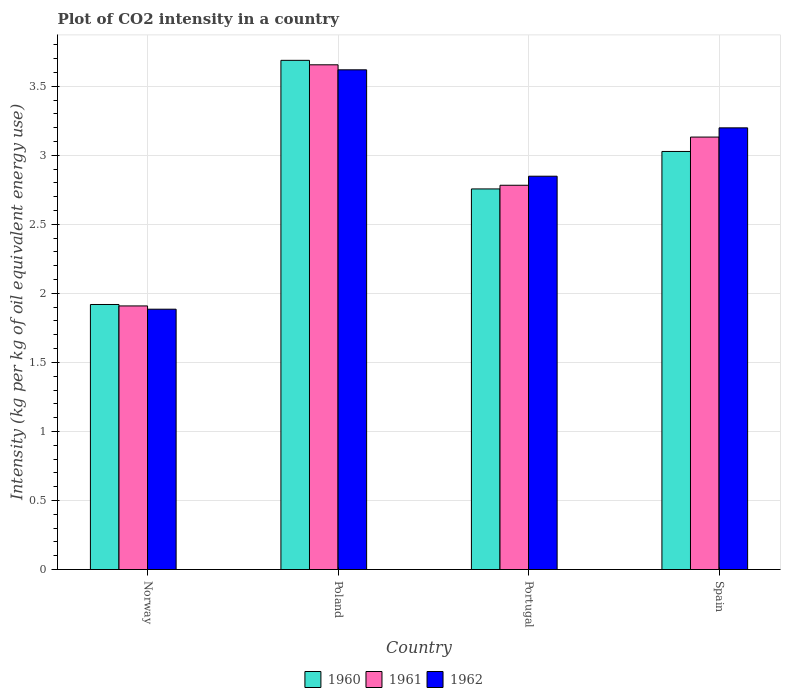How many groups of bars are there?
Provide a succinct answer. 4. Are the number of bars per tick equal to the number of legend labels?
Your answer should be compact. Yes. Are the number of bars on each tick of the X-axis equal?
Give a very brief answer. Yes. How many bars are there on the 2nd tick from the left?
Your response must be concise. 3. In how many cases, is the number of bars for a given country not equal to the number of legend labels?
Give a very brief answer. 0. What is the CO2 intensity in in 1960 in Norway?
Provide a succinct answer. 1.92. Across all countries, what is the maximum CO2 intensity in in 1961?
Your response must be concise. 3.66. Across all countries, what is the minimum CO2 intensity in in 1962?
Make the answer very short. 1.89. In which country was the CO2 intensity in in 1960 maximum?
Provide a succinct answer. Poland. What is the total CO2 intensity in in 1962 in the graph?
Make the answer very short. 11.55. What is the difference between the CO2 intensity in in 1961 in Poland and that in Spain?
Your response must be concise. 0.52. What is the difference between the CO2 intensity in in 1960 in Portugal and the CO2 intensity in in 1961 in Spain?
Make the answer very short. -0.38. What is the average CO2 intensity in in 1961 per country?
Provide a short and direct response. 2.87. What is the difference between the CO2 intensity in of/in 1961 and CO2 intensity in of/in 1962 in Norway?
Provide a succinct answer. 0.02. What is the ratio of the CO2 intensity in in 1962 in Portugal to that in Spain?
Offer a terse response. 0.89. Is the difference between the CO2 intensity in in 1961 in Poland and Spain greater than the difference between the CO2 intensity in in 1962 in Poland and Spain?
Provide a succinct answer. Yes. What is the difference between the highest and the second highest CO2 intensity in in 1962?
Ensure brevity in your answer.  0.35. What is the difference between the highest and the lowest CO2 intensity in in 1960?
Keep it short and to the point. 1.77. In how many countries, is the CO2 intensity in in 1962 greater than the average CO2 intensity in in 1962 taken over all countries?
Ensure brevity in your answer.  2. Is the sum of the CO2 intensity in in 1962 in Norway and Portugal greater than the maximum CO2 intensity in in 1960 across all countries?
Provide a short and direct response. Yes. How many bars are there?
Offer a very short reply. 12. How many countries are there in the graph?
Your answer should be very brief. 4. What is the difference between two consecutive major ticks on the Y-axis?
Give a very brief answer. 0.5. Does the graph contain any zero values?
Provide a short and direct response. No. How many legend labels are there?
Make the answer very short. 3. What is the title of the graph?
Make the answer very short. Plot of CO2 intensity in a country. Does "1994" appear as one of the legend labels in the graph?
Keep it short and to the point. No. What is the label or title of the X-axis?
Give a very brief answer. Country. What is the label or title of the Y-axis?
Offer a terse response. Intensity (kg per kg of oil equivalent energy use). What is the Intensity (kg per kg of oil equivalent energy use) in 1960 in Norway?
Your answer should be compact. 1.92. What is the Intensity (kg per kg of oil equivalent energy use) in 1961 in Norway?
Your answer should be very brief. 1.91. What is the Intensity (kg per kg of oil equivalent energy use) of 1962 in Norway?
Keep it short and to the point. 1.89. What is the Intensity (kg per kg of oil equivalent energy use) of 1960 in Poland?
Offer a very short reply. 3.69. What is the Intensity (kg per kg of oil equivalent energy use) in 1961 in Poland?
Offer a terse response. 3.66. What is the Intensity (kg per kg of oil equivalent energy use) of 1962 in Poland?
Give a very brief answer. 3.62. What is the Intensity (kg per kg of oil equivalent energy use) of 1960 in Portugal?
Make the answer very short. 2.76. What is the Intensity (kg per kg of oil equivalent energy use) in 1961 in Portugal?
Offer a very short reply. 2.78. What is the Intensity (kg per kg of oil equivalent energy use) of 1962 in Portugal?
Your response must be concise. 2.85. What is the Intensity (kg per kg of oil equivalent energy use) in 1960 in Spain?
Ensure brevity in your answer.  3.03. What is the Intensity (kg per kg of oil equivalent energy use) of 1961 in Spain?
Your answer should be compact. 3.13. What is the Intensity (kg per kg of oil equivalent energy use) of 1962 in Spain?
Provide a succinct answer. 3.2. Across all countries, what is the maximum Intensity (kg per kg of oil equivalent energy use) in 1960?
Ensure brevity in your answer.  3.69. Across all countries, what is the maximum Intensity (kg per kg of oil equivalent energy use) of 1961?
Provide a short and direct response. 3.66. Across all countries, what is the maximum Intensity (kg per kg of oil equivalent energy use) of 1962?
Keep it short and to the point. 3.62. Across all countries, what is the minimum Intensity (kg per kg of oil equivalent energy use) of 1960?
Ensure brevity in your answer.  1.92. Across all countries, what is the minimum Intensity (kg per kg of oil equivalent energy use) in 1961?
Provide a short and direct response. 1.91. Across all countries, what is the minimum Intensity (kg per kg of oil equivalent energy use) of 1962?
Offer a terse response. 1.89. What is the total Intensity (kg per kg of oil equivalent energy use) in 1960 in the graph?
Your response must be concise. 11.39. What is the total Intensity (kg per kg of oil equivalent energy use) of 1961 in the graph?
Offer a terse response. 11.48. What is the total Intensity (kg per kg of oil equivalent energy use) of 1962 in the graph?
Make the answer very short. 11.55. What is the difference between the Intensity (kg per kg of oil equivalent energy use) of 1960 in Norway and that in Poland?
Offer a very short reply. -1.77. What is the difference between the Intensity (kg per kg of oil equivalent energy use) of 1961 in Norway and that in Poland?
Your answer should be very brief. -1.75. What is the difference between the Intensity (kg per kg of oil equivalent energy use) in 1962 in Norway and that in Poland?
Provide a short and direct response. -1.73. What is the difference between the Intensity (kg per kg of oil equivalent energy use) of 1960 in Norway and that in Portugal?
Your response must be concise. -0.84. What is the difference between the Intensity (kg per kg of oil equivalent energy use) of 1961 in Norway and that in Portugal?
Ensure brevity in your answer.  -0.87. What is the difference between the Intensity (kg per kg of oil equivalent energy use) of 1962 in Norway and that in Portugal?
Give a very brief answer. -0.96. What is the difference between the Intensity (kg per kg of oil equivalent energy use) of 1960 in Norway and that in Spain?
Your answer should be very brief. -1.11. What is the difference between the Intensity (kg per kg of oil equivalent energy use) of 1961 in Norway and that in Spain?
Your answer should be very brief. -1.22. What is the difference between the Intensity (kg per kg of oil equivalent energy use) of 1962 in Norway and that in Spain?
Offer a very short reply. -1.31. What is the difference between the Intensity (kg per kg of oil equivalent energy use) of 1960 in Poland and that in Portugal?
Offer a very short reply. 0.93. What is the difference between the Intensity (kg per kg of oil equivalent energy use) in 1961 in Poland and that in Portugal?
Make the answer very short. 0.87. What is the difference between the Intensity (kg per kg of oil equivalent energy use) in 1962 in Poland and that in Portugal?
Offer a very short reply. 0.77. What is the difference between the Intensity (kg per kg of oil equivalent energy use) in 1960 in Poland and that in Spain?
Your answer should be compact. 0.66. What is the difference between the Intensity (kg per kg of oil equivalent energy use) in 1961 in Poland and that in Spain?
Offer a terse response. 0.52. What is the difference between the Intensity (kg per kg of oil equivalent energy use) in 1962 in Poland and that in Spain?
Offer a terse response. 0.42. What is the difference between the Intensity (kg per kg of oil equivalent energy use) in 1960 in Portugal and that in Spain?
Offer a very short reply. -0.27. What is the difference between the Intensity (kg per kg of oil equivalent energy use) in 1961 in Portugal and that in Spain?
Your answer should be compact. -0.35. What is the difference between the Intensity (kg per kg of oil equivalent energy use) in 1962 in Portugal and that in Spain?
Your answer should be very brief. -0.35. What is the difference between the Intensity (kg per kg of oil equivalent energy use) in 1960 in Norway and the Intensity (kg per kg of oil equivalent energy use) in 1961 in Poland?
Offer a terse response. -1.74. What is the difference between the Intensity (kg per kg of oil equivalent energy use) of 1960 in Norway and the Intensity (kg per kg of oil equivalent energy use) of 1962 in Poland?
Your response must be concise. -1.7. What is the difference between the Intensity (kg per kg of oil equivalent energy use) of 1961 in Norway and the Intensity (kg per kg of oil equivalent energy use) of 1962 in Poland?
Offer a terse response. -1.71. What is the difference between the Intensity (kg per kg of oil equivalent energy use) in 1960 in Norway and the Intensity (kg per kg of oil equivalent energy use) in 1961 in Portugal?
Give a very brief answer. -0.86. What is the difference between the Intensity (kg per kg of oil equivalent energy use) in 1960 in Norway and the Intensity (kg per kg of oil equivalent energy use) in 1962 in Portugal?
Your response must be concise. -0.93. What is the difference between the Intensity (kg per kg of oil equivalent energy use) of 1961 in Norway and the Intensity (kg per kg of oil equivalent energy use) of 1962 in Portugal?
Your answer should be very brief. -0.94. What is the difference between the Intensity (kg per kg of oil equivalent energy use) in 1960 in Norway and the Intensity (kg per kg of oil equivalent energy use) in 1961 in Spain?
Give a very brief answer. -1.21. What is the difference between the Intensity (kg per kg of oil equivalent energy use) of 1960 in Norway and the Intensity (kg per kg of oil equivalent energy use) of 1962 in Spain?
Your answer should be compact. -1.28. What is the difference between the Intensity (kg per kg of oil equivalent energy use) of 1961 in Norway and the Intensity (kg per kg of oil equivalent energy use) of 1962 in Spain?
Provide a succinct answer. -1.29. What is the difference between the Intensity (kg per kg of oil equivalent energy use) in 1960 in Poland and the Intensity (kg per kg of oil equivalent energy use) in 1961 in Portugal?
Provide a succinct answer. 0.9. What is the difference between the Intensity (kg per kg of oil equivalent energy use) of 1960 in Poland and the Intensity (kg per kg of oil equivalent energy use) of 1962 in Portugal?
Give a very brief answer. 0.84. What is the difference between the Intensity (kg per kg of oil equivalent energy use) in 1961 in Poland and the Intensity (kg per kg of oil equivalent energy use) in 1962 in Portugal?
Give a very brief answer. 0.81. What is the difference between the Intensity (kg per kg of oil equivalent energy use) of 1960 in Poland and the Intensity (kg per kg of oil equivalent energy use) of 1961 in Spain?
Make the answer very short. 0.56. What is the difference between the Intensity (kg per kg of oil equivalent energy use) in 1960 in Poland and the Intensity (kg per kg of oil equivalent energy use) in 1962 in Spain?
Offer a terse response. 0.49. What is the difference between the Intensity (kg per kg of oil equivalent energy use) of 1961 in Poland and the Intensity (kg per kg of oil equivalent energy use) of 1962 in Spain?
Your answer should be very brief. 0.46. What is the difference between the Intensity (kg per kg of oil equivalent energy use) in 1960 in Portugal and the Intensity (kg per kg of oil equivalent energy use) in 1961 in Spain?
Your answer should be very brief. -0.38. What is the difference between the Intensity (kg per kg of oil equivalent energy use) in 1960 in Portugal and the Intensity (kg per kg of oil equivalent energy use) in 1962 in Spain?
Offer a very short reply. -0.44. What is the difference between the Intensity (kg per kg of oil equivalent energy use) in 1961 in Portugal and the Intensity (kg per kg of oil equivalent energy use) in 1962 in Spain?
Ensure brevity in your answer.  -0.42. What is the average Intensity (kg per kg of oil equivalent energy use) in 1960 per country?
Offer a very short reply. 2.85. What is the average Intensity (kg per kg of oil equivalent energy use) of 1961 per country?
Give a very brief answer. 2.87. What is the average Intensity (kg per kg of oil equivalent energy use) of 1962 per country?
Give a very brief answer. 2.89. What is the difference between the Intensity (kg per kg of oil equivalent energy use) of 1960 and Intensity (kg per kg of oil equivalent energy use) of 1961 in Norway?
Provide a succinct answer. 0.01. What is the difference between the Intensity (kg per kg of oil equivalent energy use) of 1960 and Intensity (kg per kg of oil equivalent energy use) of 1962 in Norway?
Offer a terse response. 0.03. What is the difference between the Intensity (kg per kg of oil equivalent energy use) in 1961 and Intensity (kg per kg of oil equivalent energy use) in 1962 in Norway?
Your response must be concise. 0.02. What is the difference between the Intensity (kg per kg of oil equivalent energy use) of 1960 and Intensity (kg per kg of oil equivalent energy use) of 1961 in Poland?
Keep it short and to the point. 0.03. What is the difference between the Intensity (kg per kg of oil equivalent energy use) in 1960 and Intensity (kg per kg of oil equivalent energy use) in 1962 in Poland?
Your answer should be very brief. 0.07. What is the difference between the Intensity (kg per kg of oil equivalent energy use) in 1961 and Intensity (kg per kg of oil equivalent energy use) in 1962 in Poland?
Ensure brevity in your answer.  0.04. What is the difference between the Intensity (kg per kg of oil equivalent energy use) in 1960 and Intensity (kg per kg of oil equivalent energy use) in 1961 in Portugal?
Your answer should be compact. -0.03. What is the difference between the Intensity (kg per kg of oil equivalent energy use) in 1960 and Intensity (kg per kg of oil equivalent energy use) in 1962 in Portugal?
Provide a short and direct response. -0.09. What is the difference between the Intensity (kg per kg of oil equivalent energy use) of 1961 and Intensity (kg per kg of oil equivalent energy use) of 1962 in Portugal?
Your response must be concise. -0.07. What is the difference between the Intensity (kg per kg of oil equivalent energy use) in 1960 and Intensity (kg per kg of oil equivalent energy use) in 1961 in Spain?
Make the answer very short. -0.1. What is the difference between the Intensity (kg per kg of oil equivalent energy use) in 1960 and Intensity (kg per kg of oil equivalent energy use) in 1962 in Spain?
Offer a very short reply. -0.17. What is the difference between the Intensity (kg per kg of oil equivalent energy use) of 1961 and Intensity (kg per kg of oil equivalent energy use) of 1962 in Spain?
Provide a succinct answer. -0.07. What is the ratio of the Intensity (kg per kg of oil equivalent energy use) of 1960 in Norway to that in Poland?
Your answer should be compact. 0.52. What is the ratio of the Intensity (kg per kg of oil equivalent energy use) of 1961 in Norway to that in Poland?
Give a very brief answer. 0.52. What is the ratio of the Intensity (kg per kg of oil equivalent energy use) of 1962 in Norway to that in Poland?
Your answer should be compact. 0.52. What is the ratio of the Intensity (kg per kg of oil equivalent energy use) of 1960 in Norway to that in Portugal?
Your answer should be compact. 0.7. What is the ratio of the Intensity (kg per kg of oil equivalent energy use) in 1961 in Norway to that in Portugal?
Your answer should be compact. 0.69. What is the ratio of the Intensity (kg per kg of oil equivalent energy use) of 1962 in Norway to that in Portugal?
Your answer should be very brief. 0.66. What is the ratio of the Intensity (kg per kg of oil equivalent energy use) in 1960 in Norway to that in Spain?
Your answer should be compact. 0.63. What is the ratio of the Intensity (kg per kg of oil equivalent energy use) of 1961 in Norway to that in Spain?
Provide a short and direct response. 0.61. What is the ratio of the Intensity (kg per kg of oil equivalent energy use) of 1962 in Norway to that in Spain?
Your response must be concise. 0.59. What is the ratio of the Intensity (kg per kg of oil equivalent energy use) in 1960 in Poland to that in Portugal?
Your response must be concise. 1.34. What is the ratio of the Intensity (kg per kg of oil equivalent energy use) of 1961 in Poland to that in Portugal?
Your answer should be compact. 1.31. What is the ratio of the Intensity (kg per kg of oil equivalent energy use) in 1962 in Poland to that in Portugal?
Your response must be concise. 1.27. What is the ratio of the Intensity (kg per kg of oil equivalent energy use) in 1960 in Poland to that in Spain?
Your response must be concise. 1.22. What is the ratio of the Intensity (kg per kg of oil equivalent energy use) in 1961 in Poland to that in Spain?
Ensure brevity in your answer.  1.17. What is the ratio of the Intensity (kg per kg of oil equivalent energy use) of 1962 in Poland to that in Spain?
Your response must be concise. 1.13. What is the ratio of the Intensity (kg per kg of oil equivalent energy use) of 1960 in Portugal to that in Spain?
Offer a terse response. 0.91. What is the ratio of the Intensity (kg per kg of oil equivalent energy use) of 1961 in Portugal to that in Spain?
Keep it short and to the point. 0.89. What is the ratio of the Intensity (kg per kg of oil equivalent energy use) in 1962 in Portugal to that in Spain?
Provide a short and direct response. 0.89. What is the difference between the highest and the second highest Intensity (kg per kg of oil equivalent energy use) of 1960?
Provide a short and direct response. 0.66. What is the difference between the highest and the second highest Intensity (kg per kg of oil equivalent energy use) in 1961?
Your answer should be compact. 0.52. What is the difference between the highest and the second highest Intensity (kg per kg of oil equivalent energy use) in 1962?
Ensure brevity in your answer.  0.42. What is the difference between the highest and the lowest Intensity (kg per kg of oil equivalent energy use) of 1960?
Ensure brevity in your answer.  1.77. What is the difference between the highest and the lowest Intensity (kg per kg of oil equivalent energy use) in 1961?
Your response must be concise. 1.75. What is the difference between the highest and the lowest Intensity (kg per kg of oil equivalent energy use) in 1962?
Give a very brief answer. 1.73. 